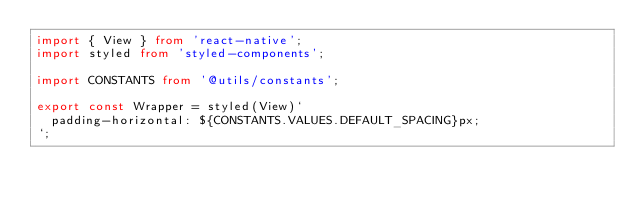Convert code to text. <code><loc_0><loc_0><loc_500><loc_500><_TypeScript_>import { View } from 'react-native';
import styled from 'styled-components';

import CONSTANTS from '@utils/constants';

export const Wrapper = styled(View)`
  padding-horizontal: ${CONSTANTS.VALUES.DEFAULT_SPACING}px;
`;
</code> 